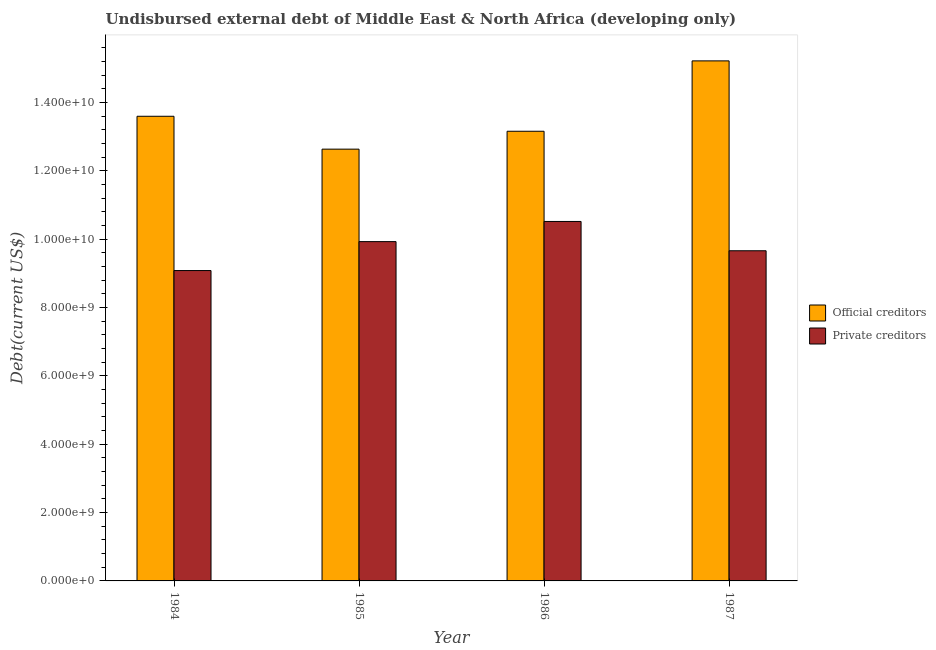How many different coloured bars are there?
Keep it short and to the point. 2. Are the number of bars per tick equal to the number of legend labels?
Offer a very short reply. Yes. Are the number of bars on each tick of the X-axis equal?
Provide a short and direct response. Yes. What is the label of the 2nd group of bars from the left?
Offer a terse response. 1985. In how many cases, is the number of bars for a given year not equal to the number of legend labels?
Provide a succinct answer. 0. What is the undisbursed external debt of official creditors in 1985?
Ensure brevity in your answer.  1.26e+1. Across all years, what is the maximum undisbursed external debt of private creditors?
Your answer should be very brief. 1.05e+1. Across all years, what is the minimum undisbursed external debt of private creditors?
Provide a succinct answer. 9.08e+09. What is the total undisbursed external debt of private creditors in the graph?
Keep it short and to the point. 3.92e+1. What is the difference between the undisbursed external debt of official creditors in 1984 and that in 1986?
Provide a short and direct response. 4.39e+08. What is the difference between the undisbursed external debt of private creditors in 1984 and the undisbursed external debt of official creditors in 1987?
Your response must be concise. -5.79e+08. What is the average undisbursed external debt of private creditors per year?
Provide a succinct answer. 9.80e+09. In how many years, is the undisbursed external debt of private creditors greater than 8000000000 US$?
Give a very brief answer. 4. What is the ratio of the undisbursed external debt of official creditors in 1984 to that in 1986?
Provide a succinct answer. 1.03. Is the difference between the undisbursed external debt of private creditors in 1986 and 1987 greater than the difference between the undisbursed external debt of official creditors in 1986 and 1987?
Give a very brief answer. No. What is the difference between the highest and the second highest undisbursed external debt of official creditors?
Offer a very short reply. 1.62e+09. What is the difference between the highest and the lowest undisbursed external debt of official creditors?
Provide a short and direct response. 2.58e+09. In how many years, is the undisbursed external debt of official creditors greater than the average undisbursed external debt of official creditors taken over all years?
Your response must be concise. 1. What does the 1st bar from the left in 1986 represents?
Your answer should be compact. Official creditors. What does the 2nd bar from the right in 1985 represents?
Provide a short and direct response. Official creditors. How many bars are there?
Keep it short and to the point. 8. Are all the bars in the graph horizontal?
Offer a terse response. No. How many years are there in the graph?
Make the answer very short. 4. What is the difference between two consecutive major ticks on the Y-axis?
Give a very brief answer. 2.00e+09. How are the legend labels stacked?
Your answer should be very brief. Vertical. What is the title of the graph?
Offer a terse response. Undisbursed external debt of Middle East & North Africa (developing only). Does "Lowest 10% of population" appear as one of the legend labels in the graph?
Provide a succinct answer. No. What is the label or title of the Y-axis?
Offer a terse response. Debt(current US$). What is the Debt(current US$) in Official creditors in 1984?
Make the answer very short. 1.36e+1. What is the Debt(current US$) in Private creditors in 1984?
Provide a short and direct response. 9.08e+09. What is the Debt(current US$) of Official creditors in 1985?
Offer a very short reply. 1.26e+1. What is the Debt(current US$) in Private creditors in 1985?
Provide a short and direct response. 9.93e+09. What is the Debt(current US$) in Official creditors in 1986?
Keep it short and to the point. 1.32e+1. What is the Debt(current US$) in Private creditors in 1986?
Your answer should be very brief. 1.05e+1. What is the Debt(current US$) in Official creditors in 1987?
Make the answer very short. 1.52e+1. What is the Debt(current US$) in Private creditors in 1987?
Make the answer very short. 9.66e+09. Across all years, what is the maximum Debt(current US$) of Official creditors?
Provide a succinct answer. 1.52e+1. Across all years, what is the maximum Debt(current US$) in Private creditors?
Provide a succinct answer. 1.05e+1. Across all years, what is the minimum Debt(current US$) of Official creditors?
Provide a short and direct response. 1.26e+1. Across all years, what is the minimum Debt(current US$) in Private creditors?
Ensure brevity in your answer.  9.08e+09. What is the total Debt(current US$) in Official creditors in the graph?
Your answer should be very brief. 5.46e+1. What is the total Debt(current US$) of Private creditors in the graph?
Your answer should be very brief. 3.92e+1. What is the difference between the Debt(current US$) in Official creditors in 1984 and that in 1985?
Provide a short and direct response. 9.62e+08. What is the difference between the Debt(current US$) in Private creditors in 1984 and that in 1985?
Keep it short and to the point. -8.47e+08. What is the difference between the Debt(current US$) in Official creditors in 1984 and that in 1986?
Provide a short and direct response. 4.39e+08. What is the difference between the Debt(current US$) of Private creditors in 1984 and that in 1986?
Provide a short and direct response. -1.44e+09. What is the difference between the Debt(current US$) of Official creditors in 1984 and that in 1987?
Offer a very short reply. -1.62e+09. What is the difference between the Debt(current US$) in Private creditors in 1984 and that in 1987?
Provide a succinct answer. -5.79e+08. What is the difference between the Debt(current US$) of Official creditors in 1985 and that in 1986?
Provide a succinct answer. -5.23e+08. What is the difference between the Debt(current US$) of Private creditors in 1985 and that in 1986?
Your answer should be very brief. -5.90e+08. What is the difference between the Debt(current US$) of Official creditors in 1985 and that in 1987?
Your answer should be compact. -2.58e+09. What is the difference between the Debt(current US$) in Private creditors in 1985 and that in 1987?
Keep it short and to the point. 2.67e+08. What is the difference between the Debt(current US$) in Official creditors in 1986 and that in 1987?
Make the answer very short. -2.06e+09. What is the difference between the Debt(current US$) of Private creditors in 1986 and that in 1987?
Your response must be concise. 8.58e+08. What is the difference between the Debt(current US$) of Official creditors in 1984 and the Debt(current US$) of Private creditors in 1985?
Offer a terse response. 3.67e+09. What is the difference between the Debt(current US$) in Official creditors in 1984 and the Debt(current US$) in Private creditors in 1986?
Your response must be concise. 3.08e+09. What is the difference between the Debt(current US$) in Official creditors in 1984 and the Debt(current US$) in Private creditors in 1987?
Make the answer very short. 3.94e+09. What is the difference between the Debt(current US$) of Official creditors in 1985 and the Debt(current US$) of Private creditors in 1986?
Your answer should be very brief. 2.12e+09. What is the difference between the Debt(current US$) of Official creditors in 1985 and the Debt(current US$) of Private creditors in 1987?
Give a very brief answer. 2.97e+09. What is the difference between the Debt(current US$) in Official creditors in 1986 and the Debt(current US$) in Private creditors in 1987?
Your answer should be very brief. 3.50e+09. What is the average Debt(current US$) in Official creditors per year?
Offer a terse response. 1.37e+1. What is the average Debt(current US$) of Private creditors per year?
Make the answer very short. 9.80e+09. In the year 1984, what is the difference between the Debt(current US$) of Official creditors and Debt(current US$) of Private creditors?
Your response must be concise. 4.52e+09. In the year 1985, what is the difference between the Debt(current US$) of Official creditors and Debt(current US$) of Private creditors?
Provide a succinct answer. 2.71e+09. In the year 1986, what is the difference between the Debt(current US$) of Official creditors and Debt(current US$) of Private creditors?
Your response must be concise. 2.64e+09. In the year 1987, what is the difference between the Debt(current US$) of Official creditors and Debt(current US$) of Private creditors?
Keep it short and to the point. 5.56e+09. What is the ratio of the Debt(current US$) of Official creditors in 1984 to that in 1985?
Keep it short and to the point. 1.08. What is the ratio of the Debt(current US$) in Private creditors in 1984 to that in 1985?
Make the answer very short. 0.91. What is the ratio of the Debt(current US$) of Private creditors in 1984 to that in 1986?
Your answer should be compact. 0.86. What is the ratio of the Debt(current US$) of Official creditors in 1984 to that in 1987?
Make the answer very short. 0.89. What is the ratio of the Debt(current US$) in Private creditors in 1984 to that in 1987?
Offer a very short reply. 0.94. What is the ratio of the Debt(current US$) of Official creditors in 1985 to that in 1986?
Offer a terse response. 0.96. What is the ratio of the Debt(current US$) of Private creditors in 1985 to that in 1986?
Make the answer very short. 0.94. What is the ratio of the Debt(current US$) in Official creditors in 1985 to that in 1987?
Offer a terse response. 0.83. What is the ratio of the Debt(current US$) of Private creditors in 1985 to that in 1987?
Offer a very short reply. 1.03. What is the ratio of the Debt(current US$) in Official creditors in 1986 to that in 1987?
Your answer should be very brief. 0.86. What is the ratio of the Debt(current US$) in Private creditors in 1986 to that in 1987?
Your response must be concise. 1.09. What is the difference between the highest and the second highest Debt(current US$) of Official creditors?
Offer a very short reply. 1.62e+09. What is the difference between the highest and the second highest Debt(current US$) in Private creditors?
Provide a succinct answer. 5.90e+08. What is the difference between the highest and the lowest Debt(current US$) of Official creditors?
Offer a very short reply. 2.58e+09. What is the difference between the highest and the lowest Debt(current US$) of Private creditors?
Give a very brief answer. 1.44e+09. 